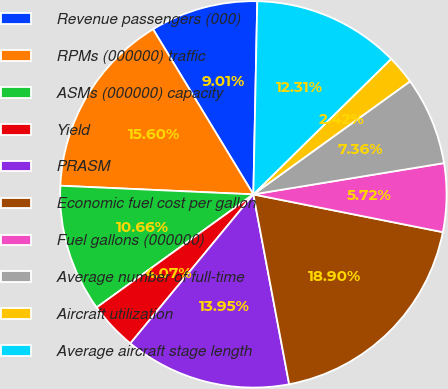Convert chart. <chart><loc_0><loc_0><loc_500><loc_500><pie_chart><fcel>Revenue passengers (000)<fcel>RPMs (000000) traffic<fcel>ASMs (000000) capacity<fcel>Yield<fcel>PRASM<fcel>Economic fuel cost per gallon<fcel>Fuel gallons (000000)<fcel>Average number of full-time<fcel>Aircraft utilization<fcel>Average aircraft stage length<nl><fcel>9.01%<fcel>15.6%<fcel>10.66%<fcel>4.07%<fcel>13.95%<fcel>18.9%<fcel>5.72%<fcel>7.36%<fcel>2.42%<fcel>12.31%<nl></chart> 